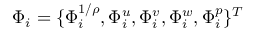Convert formula to latex. <formula><loc_0><loc_0><loc_500><loc_500>\Phi _ { i } = \{ \Phi _ { i } ^ { 1 / \rho } , \Phi _ { i } ^ { u } , \Phi _ { i } ^ { v } , \Phi _ { i } ^ { w } , \Phi _ { i } ^ { p } \} ^ { T }</formula> 